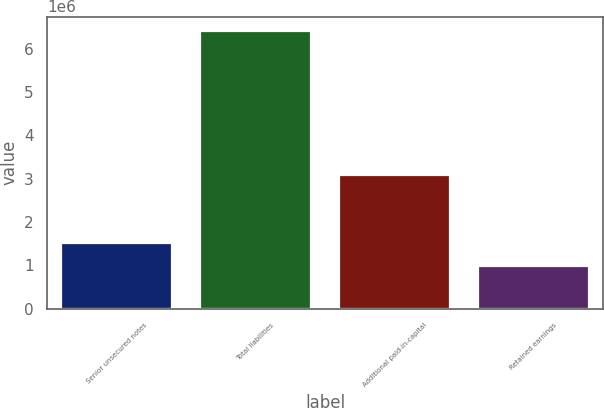<chart> <loc_0><loc_0><loc_500><loc_500><bar_chart><fcel>Senior unsecured notes<fcel>Total liabilities<fcel>Additional paid-in-capital<fcel>Retained earnings<nl><fcel>1.52345e+06<fcel>6.41506e+06<fcel>3.07916e+06<fcel>979939<nl></chart> 